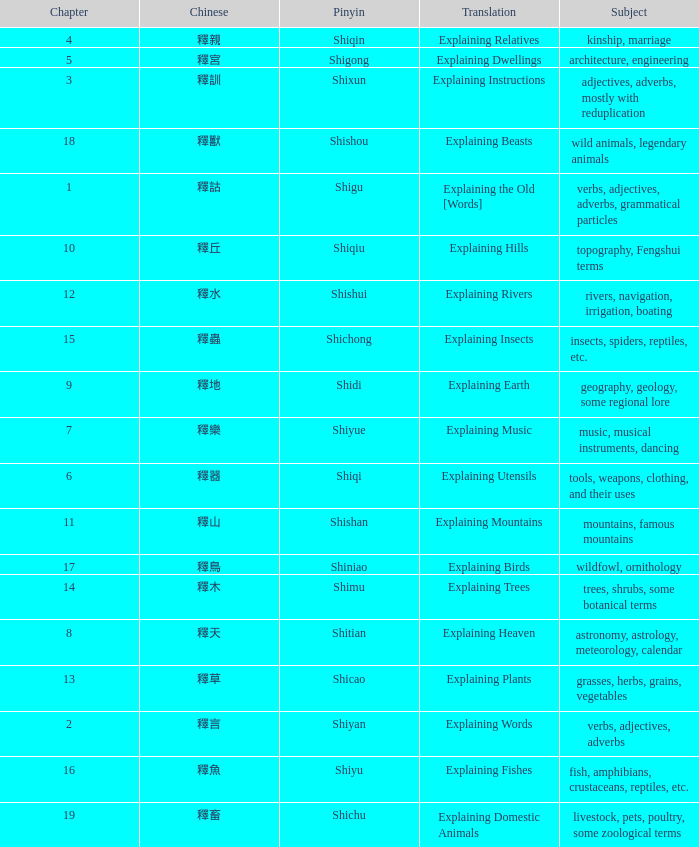Name the chapter with chinese of 釋水 12.0. 